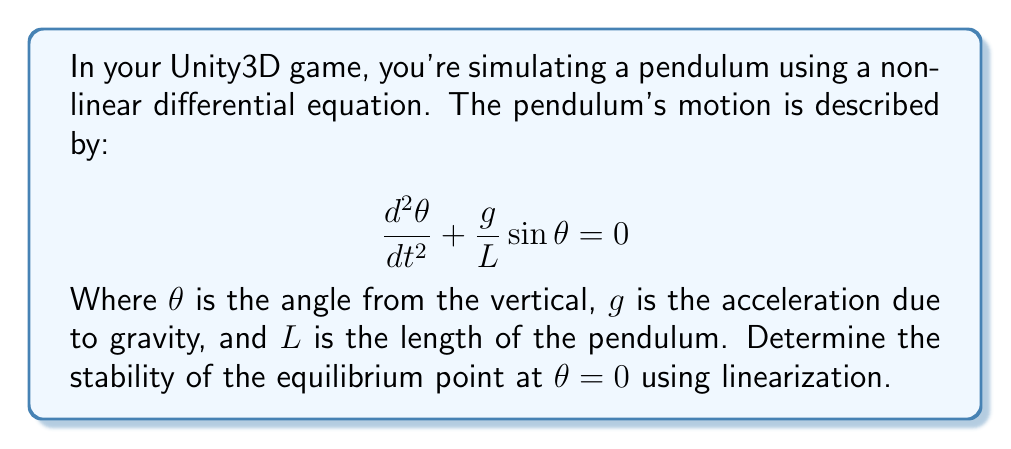Teach me how to tackle this problem. To determine the stability of the nonlinear system at the equilibrium point $\theta = 0$, we'll follow these steps:

1. Rewrite the second-order differential equation as a system of first-order equations:
   Let $x_1 = \theta$ and $x_2 = \frac{d\theta}{dt}$
   $$\frac{dx_1}{dt} = x_2$$
   $$\frac{dx_2}{dt} = -\frac{g}{L}\sin(x_1)$$

2. Find the Jacobian matrix of the system:
   $$J = \begin{bmatrix}
   \frac{\partial f_1}{\partial x_1} & \frac{\partial f_1}{\partial x_2} \\
   \frac{\partial f_2}{\partial x_1} & \frac{\partial f_2}{\partial x_2}
   \end{bmatrix} = \begin{bmatrix}
   0 & 1 \\
   -\frac{g}{L}\cos(x_1) & 0
   \end{bmatrix}$$

3. Evaluate the Jacobian at the equilibrium point $(0, 0)$:
   $$J(0,0) = \begin{bmatrix}
   0 & 1 \\
   -\frac{g}{L} & 0
   \end{bmatrix}$$

4. Calculate the eigenvalues of $J(0,0)$:
   $$\det(J(0,0) - \lambda I) = \begin{vmatrix}
   -\lambda & 1 \\
   -\frac{g}{L} & -\lambda
   \end{vmatrix} = \lambda^2 + \frac{g}{L} = 0$$
   
   $$\lambda = \pm i\sqrt{\frac{g}{L}}$$

5. Analyze the eigenvalues:
   The eigenvalues are purely imaginary conjugates, which indicates that the equilibrium point is a center.

6. Conclusion:
   The equilibrium point $\theta = 0$ is neutrally stable. In the game physics simulation, this means that small perturbations around the equilibrium will result in oscillations that neither grow nor decay over time.
Answer: Neutrally stable 